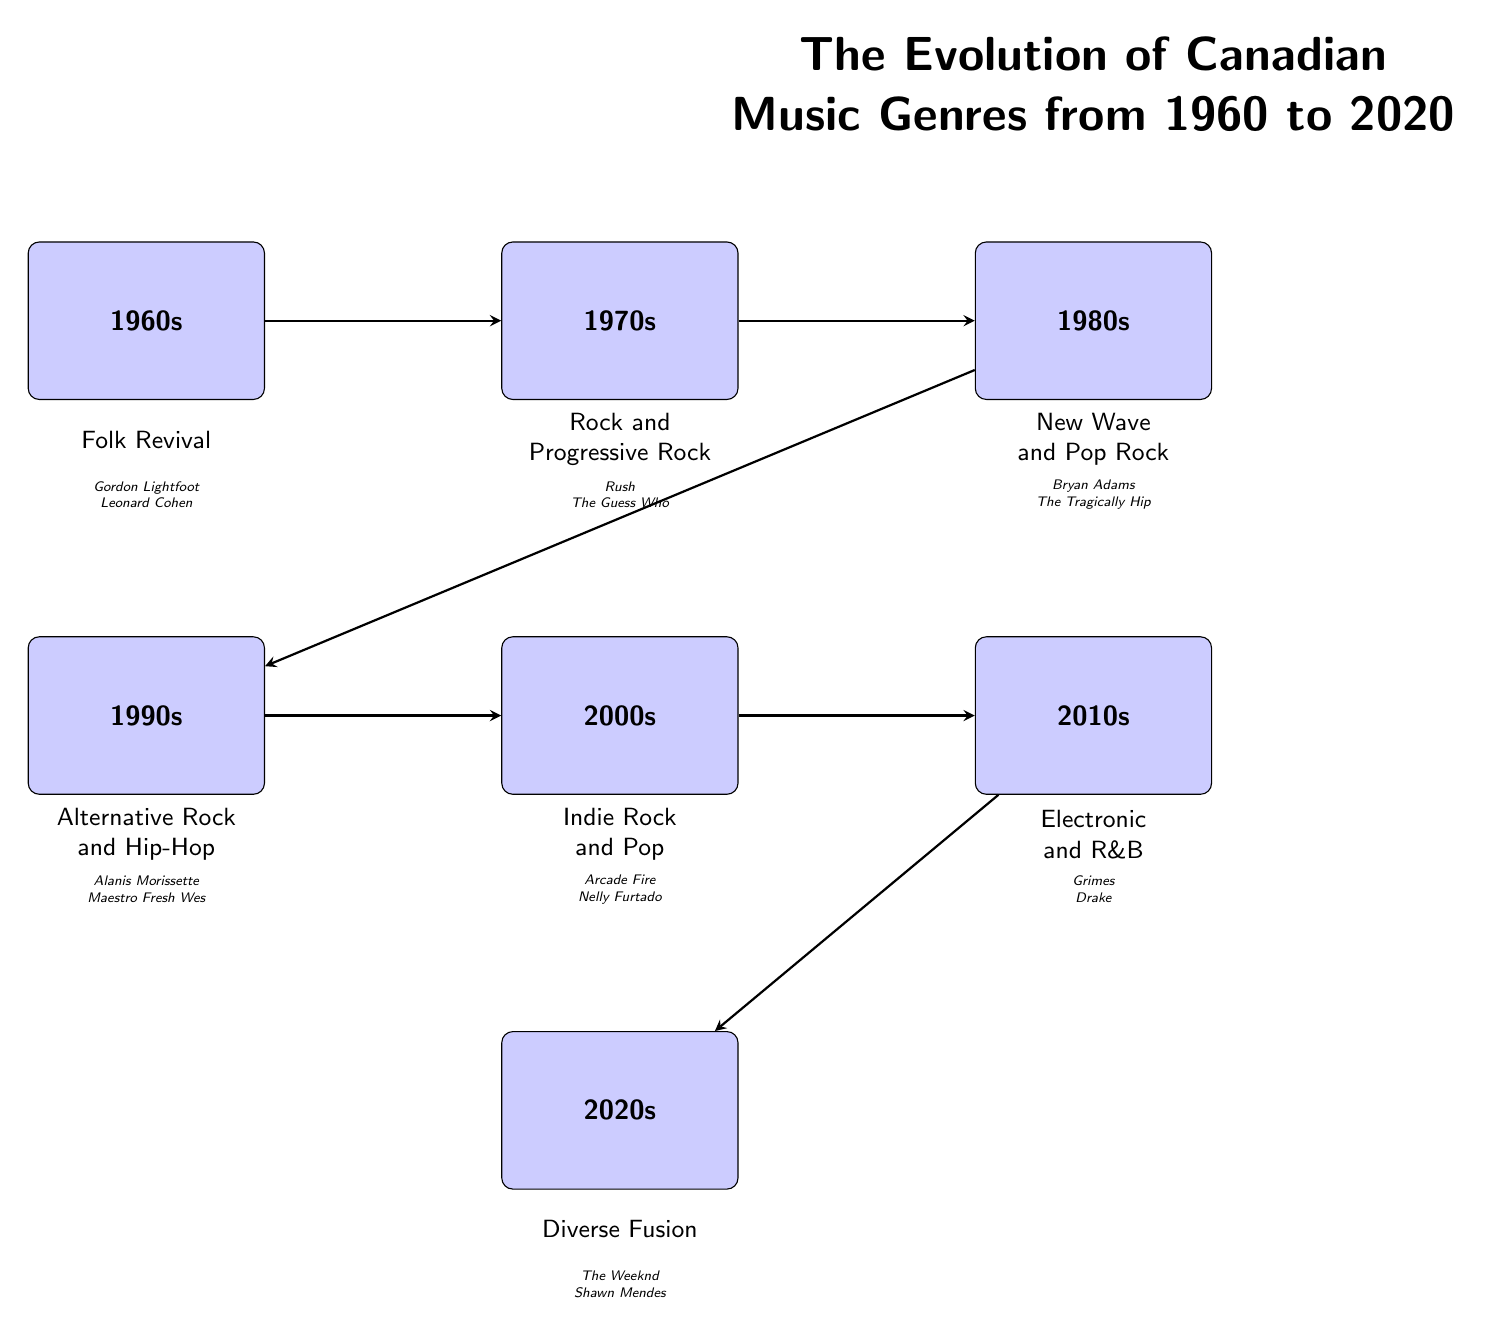What genre is associated with the 1980s in Canadian music? The diagram indicates that the genre associated with the 1980s is New Wave and Pop Rock, as it is directly listed beneath the 1980s node.
Answer: New Wave and Pop Rock Who are the artists linked to the 1990s genre? The artists linked to the 1990s genre, which is Alternative Rock and Hip-Hop, are provided in the diagram directly below that genre. They are Alanis Morissette and Maestro Fresh Wes.
Answer: Alanis Morissette, Maestro Fresh Wes How many distinct decades are represented in the diagram? The diagram displays six distinct decades, each represented by a separate node from the 1960s to the 2020s. Counting these nodes confirms the number.
Answer: 6 What is the relationship between the 2000s and 2010s? The diagram shows a direct connection (arrow) from the 2000s node to the 2010s node, indicating a chronological progression from one music genre to the next.
Answer: Arrow between 2000s and 2010s Which two decades are categorized as housing Diverse Fusion? The diagram shows that Diverse Fusion is categorized in the 2020s. The previous genre before that is found in the 2010s, indicating that the two decades around that genre are the 2010s and 2020s.
Answer: 2010s and 2020s What genre emerged after Alternative Rock and Hip-Hop in 1990s? Following the Alternative Rock and Hip-Hop genre in the timeline, the diagram shows that the next genre is Indie Rock and Pop, which belongs to the 2000s decade.
Answer: Indie Rock and Pop Which Canadian artist is associated with the genre in the 2010s? The diagram indicates that the Canadian artists associated with the genre Electronic and R&B in the 2010s are Grimes and Drake.
Answer: Grimes, Drake 